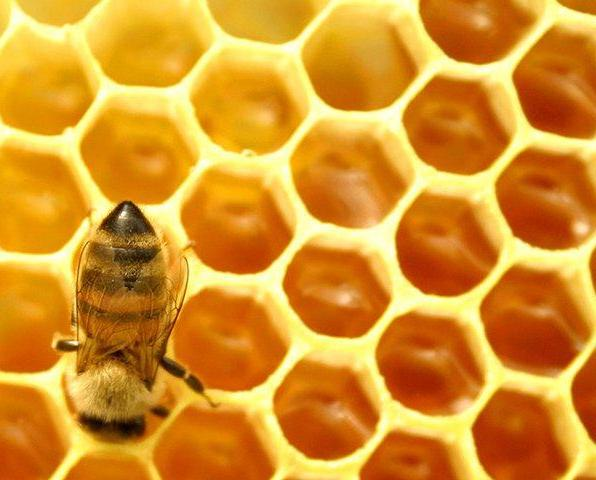Can you discuss the environmental implications of the honeycomb structure? Certainly, the honeycomb structure not only exemplifies a marvel of natural engineering but also reflects a significant environmental adaptation. It demonstrates efficient use of resources (beeswax), which bees produce from their own metabolic processes. The hexagonal pattern maximizes space while using minimal material, which is energetically favorable. This efficiency in design supports the colony's sustainability and lessens environmental extraction pressure for building materials, highlighting a form of natural resource conservation. 